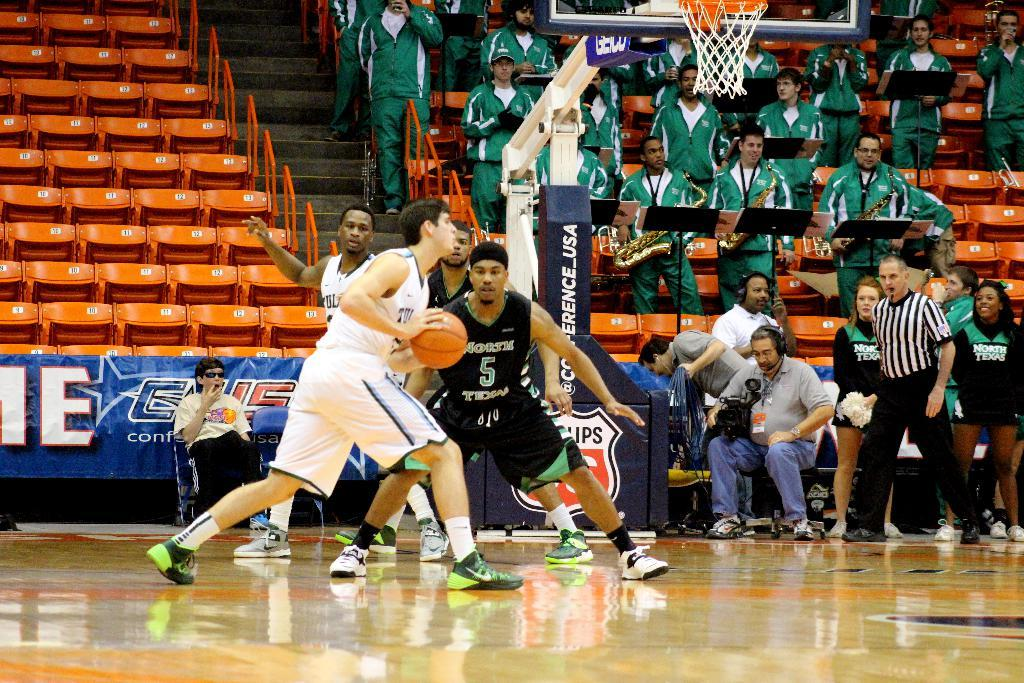<image>
Offer a succinct explanation of the picture presented. Basketball player wearing number 5 guarding another player. 